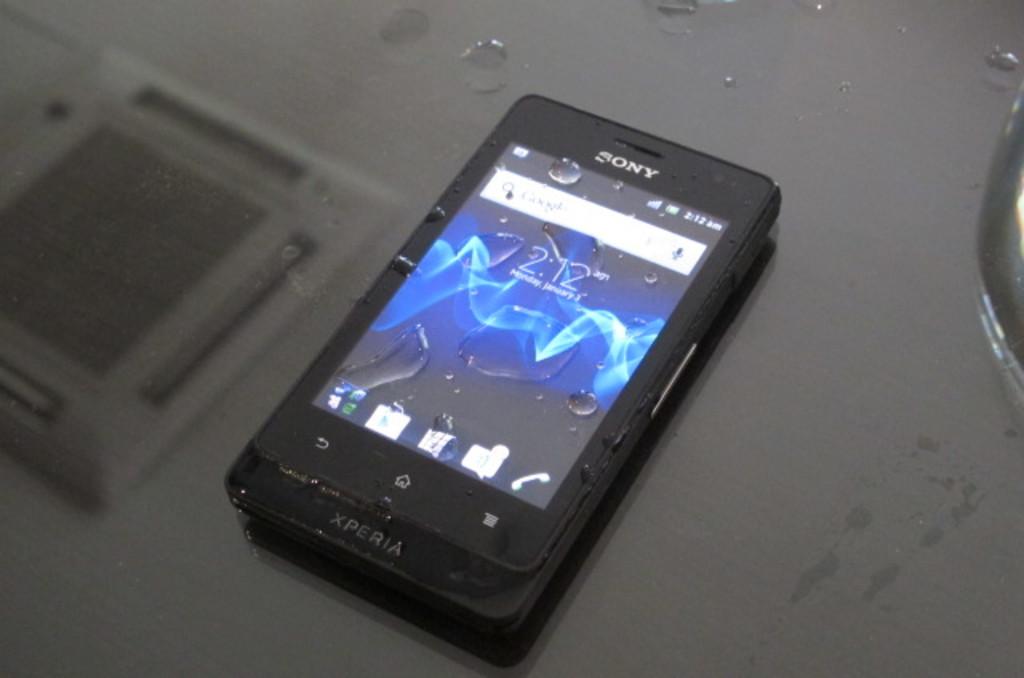What is on the white banner on the top of the screen?
Your response must be concise. Google. 